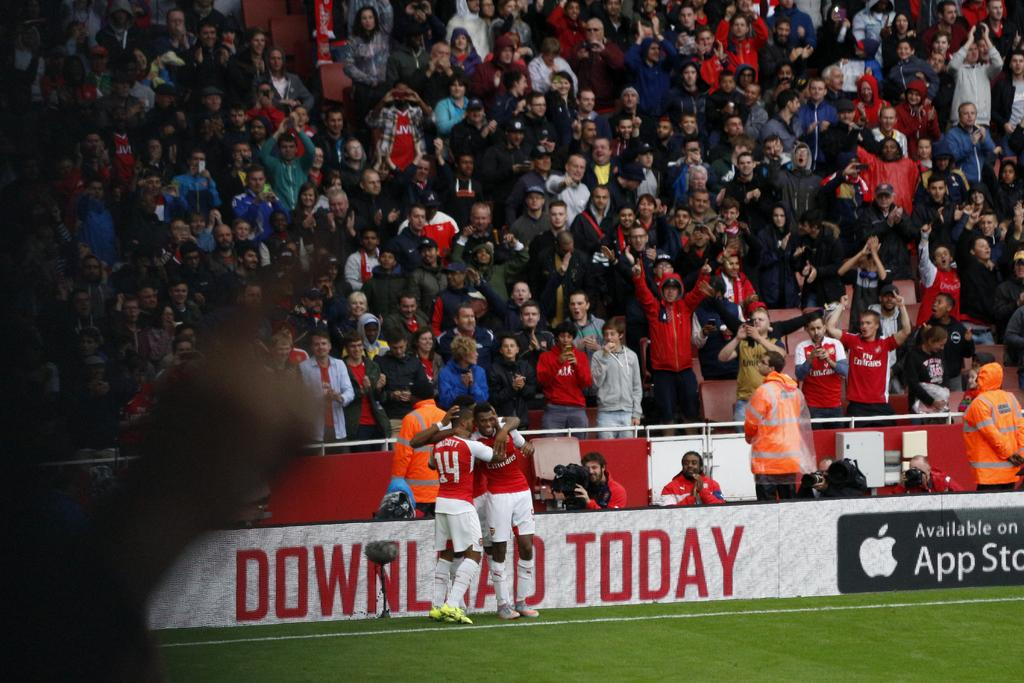What is happening in the center of the image? There are players standing in the ground in the center of the image. What can be seen in the background of the image? There is an audience in the background of the image. Where is the audience located in relation to the players? The audience is standing in stands in the background of the image. What type of hair can be seen on the players in the image? There is no information about the players' hair in the image, so it cannot be determined. How does the air quality affect the players' performance in the image? There is no information about the air quality in the image, so it cannot be determined. 